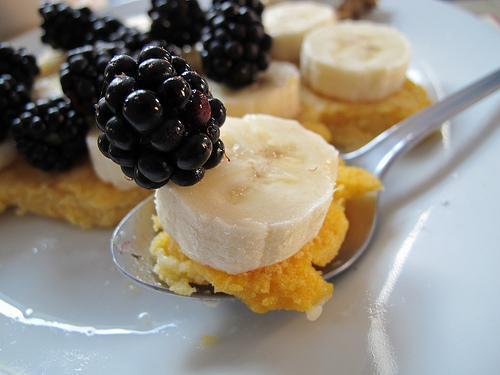How many blackberries are pictured?
Give a very brief answer. 8. How many banana slices are on the spoon?
Give a very brief answer. 1. How many banana slices can be counted?
Give a very brief answer. 5. How many plates are pictured?
Give a very brief answer. 1. 